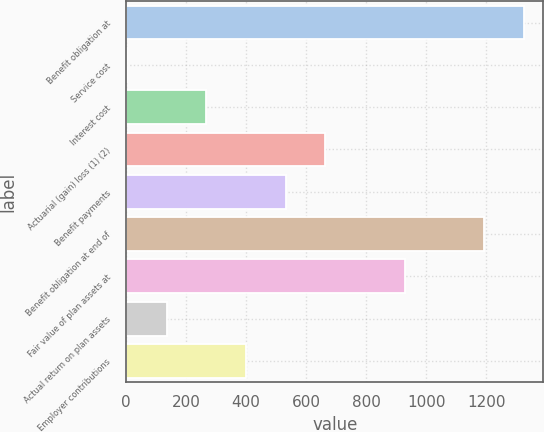<chart> <loc_0><loc_0><loc_500><loc_500><bar_chart><fcel>Benefit obligation at<fcel>Service cost<fcel>Interest cost<fcel>Actuarial (gain) loss (1) (2)<fcel>Benefit payments<fcel>Benefit obligation at end of<fcel>Fair value of plan assets at<fcel>Actual return on plan assets<fcel>Employer contributions<nl><fcel>1324<fcel>3<fcel>267.2<fcel>663.5<fcel>531.4<fcel>1191.9<fcel>927.7<fcel>135.1<fcel>399.3<nl></chart> 